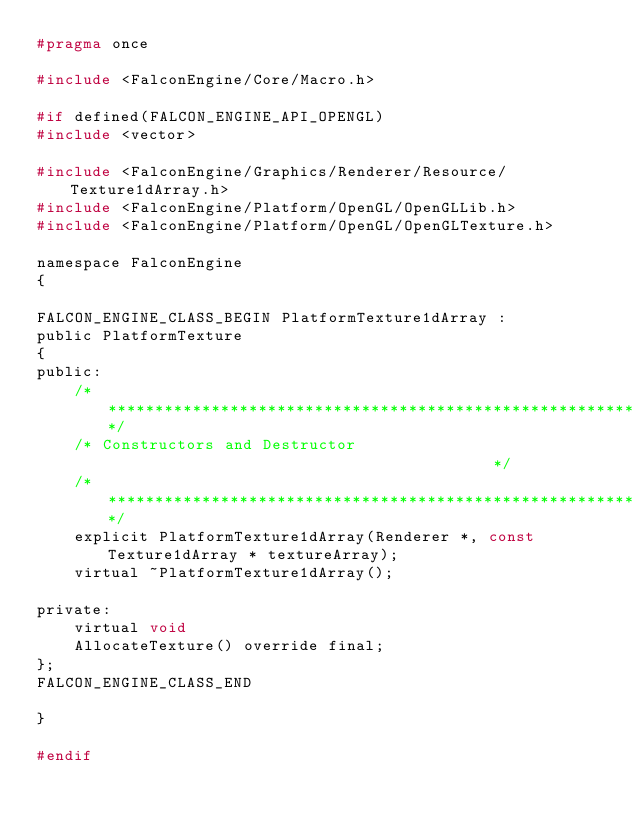<code> <loc_0><loc_0><loc_500><loc_500><_C_>#pragma once

#include <FalconEngine/Core/Macro.h>

#if defined(FALCON_ENGINE_API_OPENGL)
#include <vector>

#include <FalconEngine/Graphics/Renderer/Resource/Texture1dArray.h>
#include <FalconEngine/Platform/OpenGL/OpenGLLib.h>
#include <FalconEngine/Platform/OpenGL/OpenGLTexture.h>

namespace FalconEngine
{

FALCON_ENGINE_CLASS_BEGIN PlatformTexture1dArray :
public PlatformTexture
{
public:
    /************************************************************************/
    /* Constructors and Destructor                                          */
    /************************************************************************/
    explicit PlatformTexture1dArray(Renderer *, const Texture1dArray * textureArray);
    virtual ~PlatformTexture1dArray();

private:
    virtual void
    AllocateTexture() override final;
};
FALCON_ENGINE_CLASS_END

}

#endif</code> 